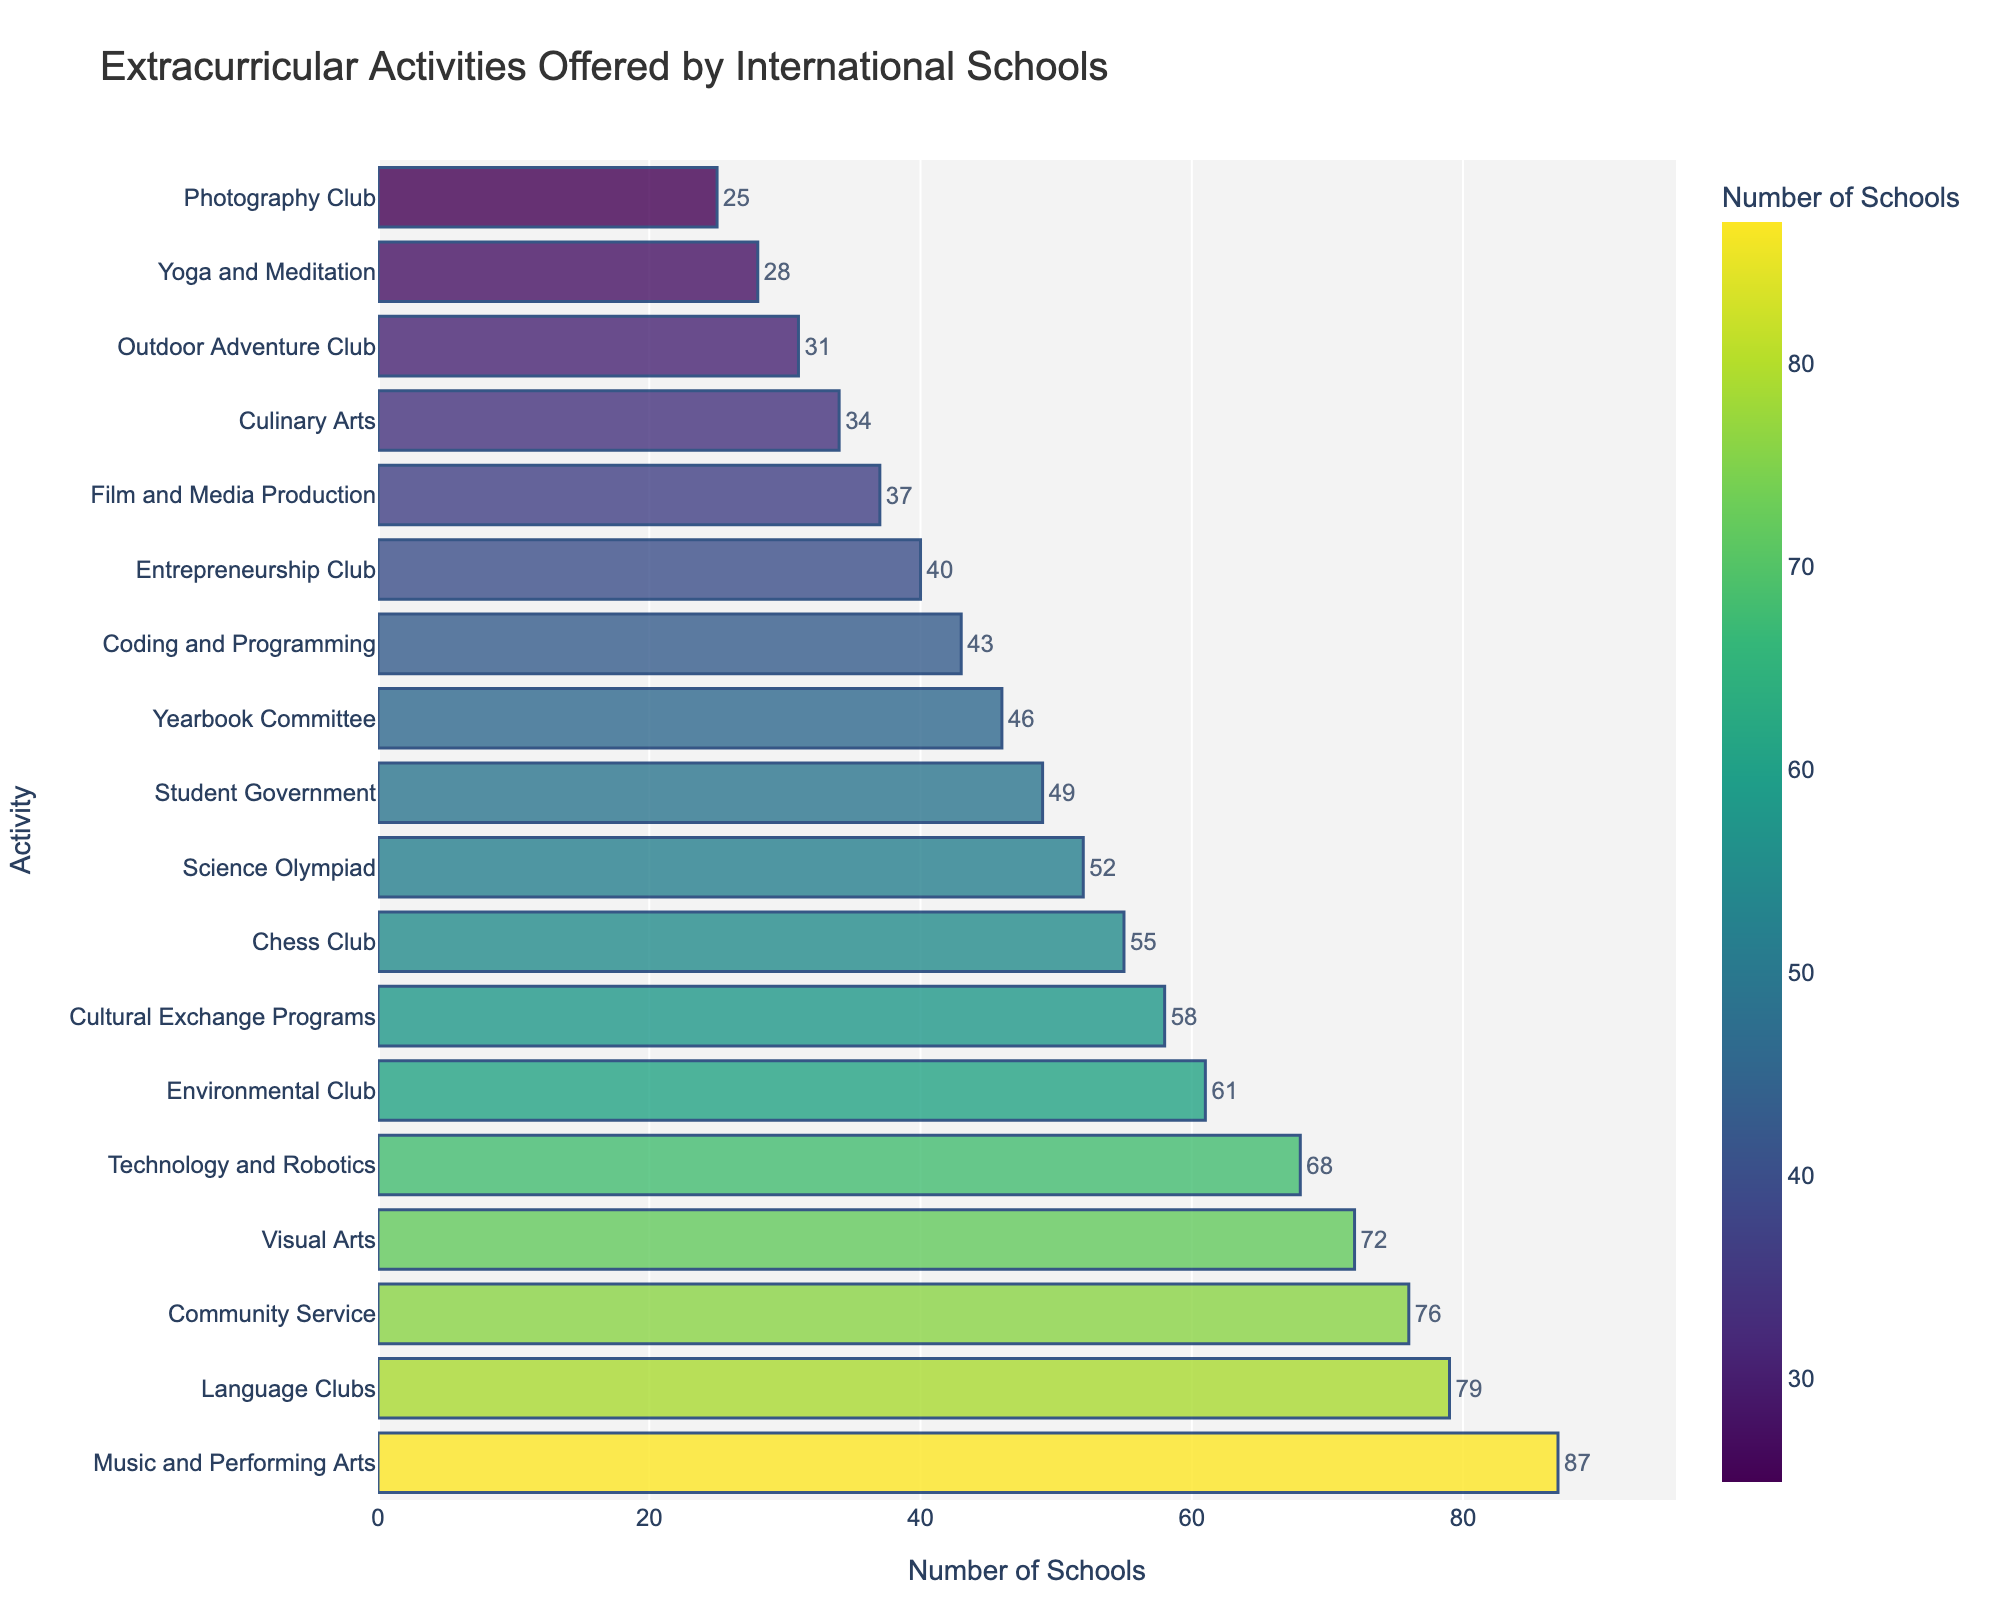Which extracurricular activity is offered by the most international schools? From the figure, the longest bar represents the activity with the highest number, which is 'Music and Performing Arts' with 87 schools offering it.
Answer: Music and Performing Arts Which activity is offered by the fewest international schools? The shortest bar represents the activity with the lowest number, which is the 'Photography Club' with 25 schools offering it.
Answer: Photography Club How many more schools offer Music and Performing Arts compared to Coding and Programming? The number of schools offering Music and Performing Arts is 87. The number offering Coding and Programming is 43. The difference is calculated as 87 - 43.
Answer: 44 What is the average number of schools offering Cultural Exchange Programs, Chess Club, and Science Olympiad? The number of schools for Cultural Exchange Programs is 58, Chess Club is 55, and Science Olympiad is 52. The average is calculated as (58 + 55 + 52) / 3.
Answer: 55 Are there more schools offering Technology and Robotics or Visual Arts? By comparing the lengths of the bars, Technology and Robotics is shorter than Visual Arts. The numbers confirm this: Technology and Robotics has 68 schools, while Visual Arts has 72 schools.
Answer: Visual Arts How many activities are offered by more than 50 schools? Count the bars that extend beyond the 50 mark: Music and Performing Arts, Language Clubs, Community Service, Visual Arts, Technology and Robotics, Environmental Club, Cultural Exchange Programs, Chess Club, and Science Olympiad. This is a total of 9 activities.
Answer: 9 What is the sum of schools offering Environmental Club and Outdoor Adventure Club? The number of schools offering Environmental Club is 61, and for Outdoor Adventure Club, it is 31. The sum is calculated as 61 + 31.
Answer: 92 Which activity has the closest number of schools offering to Yearbook Committee? Compare the values of the bars closest to Yearbook Committee (46): Coding and Programming (43), Student Government (49). Student Government is closer to 46 than Coding and Programming.
Answer: Student Government Between Community Service and Chess Club, which activity is offered by more schools and by how many? The bar for Community Service indicates 76 schools, while Chess Club indicates 55. The difference is calculated as 76 - 55.
Answer: Community Service by 21 schools 